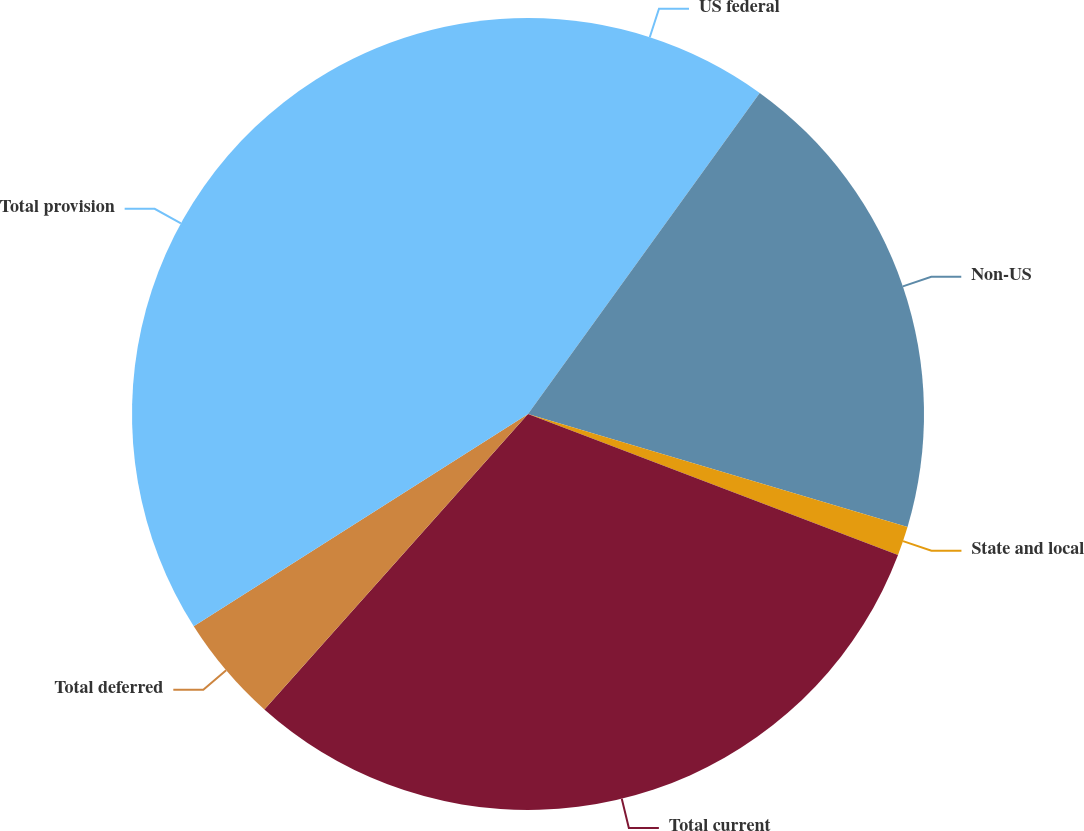<chart> <loc_0><loc_0><loc_500><loc_500><pie_chart><fcel>US federal<fcel>Non-US<fcel>State and local<fcel>Total current<fcel>Total deferred<fcel>Total provision<nl><fcel>9.95%<fcel>19.66%<fcel>1.19%<fcel>30.8%<fcel>4.4%<fcel>34.01%<nl></chart> 